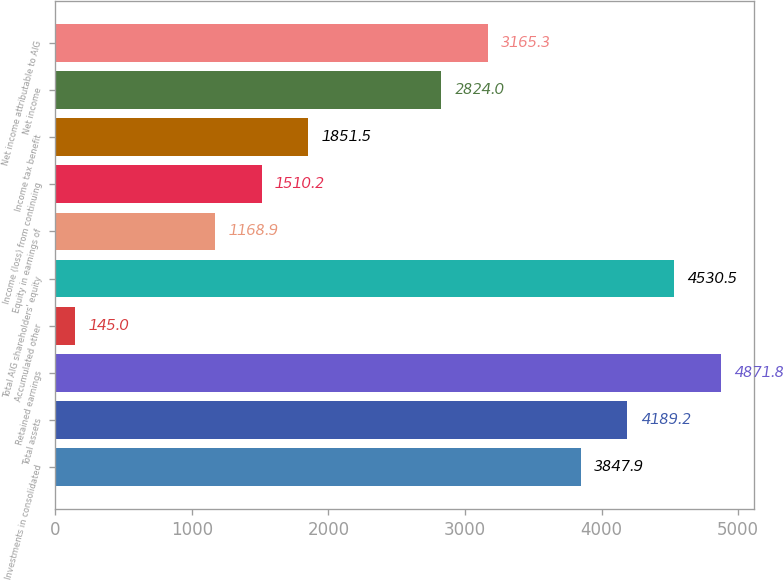<chart> <loc_0><loc_0><loc_500><loc_500><bar_chart><fcel>Investments in consolidated<fcel>Total assets<fcel>Retained earnings<fcel>Accumulated other<fcel>Total AIG shareholders' equity<fcel>Equity in earnings of<fcel>Income (loss) from continuing<fcel>Income tax benefit<fcel>Net income<fcel>Net income attributable to AIG<nl><fcel>3847.9<fcel>4189.2<fcel>4871.8<fcel>145<fcel>4530.5<fcel>1168.9<fcel>1510.2<fcel>1851.5<fcel>2824<fcel>3165.3<nl></chart> 